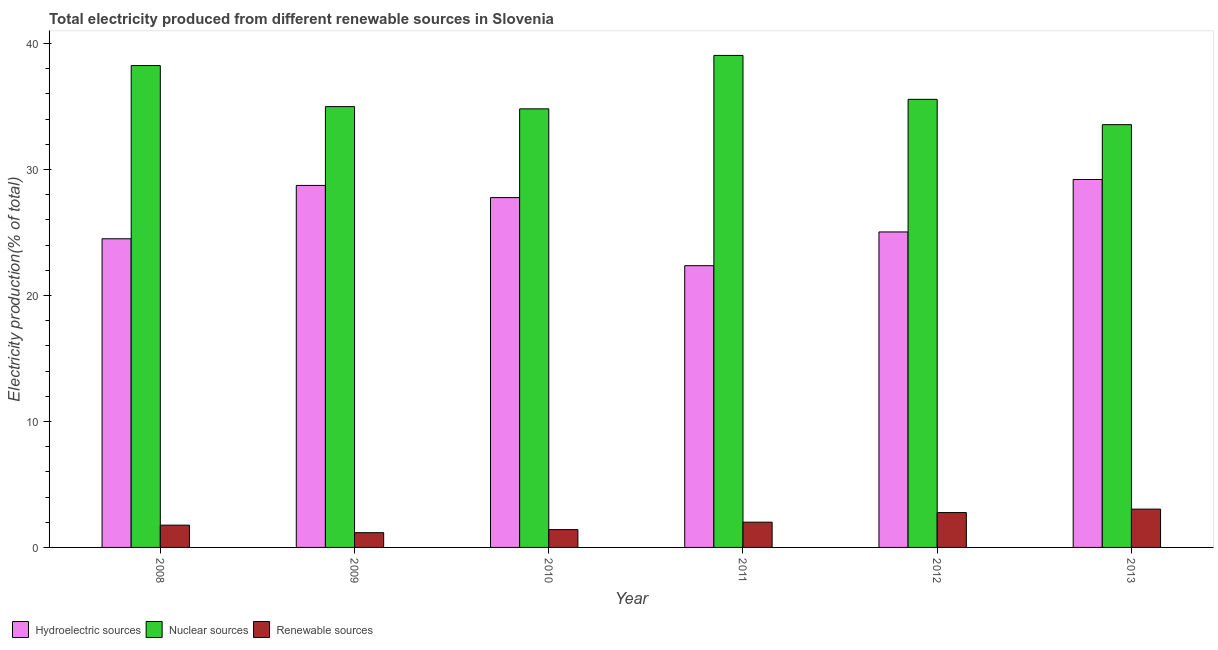How many groups of bars are there?
Offer a terse response. 6. Are the number of bars per tick equal to the number of legend labels?
Offer a very short reply. Yes. Are the number of bars on each tick of the X-axis equal?
Offer a very short reply. Yes. How many bars are there on the 5th tick from the right?
Keep it short and to the point. 3. What is the label of the 4th group of bars from the left?
Your answer should be very brief. 2011. What is the percentage of electricity produced by hydroelectric sources in 2011?
Provide a succinct answer. 22.37. Across all years, what is the maximum percentage of electricity produced by nuclear sources?
Your answer should be compact. 39.06. Across all years, what is the minimum percentage of electricity produced by nuclear sources?
Keep it short and to the point. 33.56. In which year was the percentage of electricity produced by renewable sources maximum?
Offer a very short reply. 2013. What is the total percentage of electricity produced by nuclear sources in the graph?
Your answer should be compact. 216.25. What is the difference between the percentage of electricity produced by hydroelectric sources in 2011 and that in 2012?
Provide a short and direct response. -2.68. What is the difference between the percentage of electricity produced by nuclear sources in 2011 and the percentage of electricity produced by renewable sources in 2012?
Provide a succinct answer. 3.49. What is the average percentage of electricity produced by renewable sources per year?
Your answer should be compact. 2.03. In how many years, is the percentage of electricity produced by hydroelectric sources greater than 2 %?
Keep it short and to the point. 6. What is the ratio of the percentage of electricity produced by nuclear sources in 2012 to that in 2013?
Offer a terse response. 1.06. Is the percentage of electricity produced by renewable sources in 2009 less than that in 2013?
Your answer should be compact. Yes. What is the difference between the highest and the second highest percentage of electricity produced by renewable sources?
Make the answer very short. 0.27. What is the difference between the highest and the lowest percentage of electricity produced by nuclear sources?
Ensure brevity in your answer.  5.5. In how many years, is the percentage of electricity produced by nuclear sources greater than the average percentage of electricity produced by nuclear sources taken over all years?
Ensure brevity in your answer.  2. Is the sum of the percentage of electricity produced by renewable sources in 2012 and 2013 greater than the maximum percentage of electricity produced by hydroelectric sources across all years?
Your answer should be compact. Yes. What does the 3rd bar from the left in 2011 represents?
Offer a terse response. Renewable sources. What does the 3rd bar from the right in 2008 represents?
Provide a succinct answer. Hydroelectric sources. Are all the bars in the graph horizontal?
Your answer should be compact. No. How many years are there in the graph?
Provide a short and direct response. 6. What is the difference between two consecutive major ticks on the Y-axis?
Provide a short and direct response. 10. Are the values on the major ticks of Y-axis written in scientific E-notation?
Provide a short and direct response. No. Where does the legend appear in the graph?
Give a very brief answer. Bottom left. How are the legend labels stacked?
Your response must be concise. Horizontal. What is the title of the graph?
Offer a terse response. Total electricity produced from different renewable sources in Slovenia. Does "Social Protection and Labor" appear as one of the legend labels in the graph?
Your response must be concise. No. What is the Electricity production(% of total) of Hydroelectric sources in 2008?
Provide a succinct answer. 24.5. What is the Electricity production(% of total) of Nuclear sources in 2008?
Ensure brevity in your answer.  38.25. What is the Electricity production(% of total) in Renewable sources in 2008?
Provide a succinct answer. 1.77. What is the Electricity production(% of total) of Hydroelectric sources in 2009?
Offer a very short reply. 28.74. What is the Electricity production(% of total) of Nuclear sources in 2009?
Ensure brevity in your answer.  34.99. What is the Electricity production(% of total) of Renewable sources in 2009?
Your answer should be compact. 1.17. What is the Electricity production(% of total) in Hydroelectric sources in 2010?
Your answer should be very brief. 27.77. What is the Electricity production(% of total) of Nuclear sources in 2010?
Ensure brevity in your answer.  34.82. What is the Electricity production(% of total) in Renewable sources in 2010?
Provide a short and direct response. 1.42. What is the Electricity production(% of total) of Hydroelectric sources in 2011?
Offer a very short reply. 22.37. What is the Electricity production(% of total) of Nuclear sources in 2011?
Your response must be concise. 39.06. What is the Electricity production(% of total) in Renewable sources in 2011?
Make the answer very short. 2. What is the Electricity production(% of total) in Hydroelectric sources in 2012?
Give a very brief answer. 25.04. What is the Electricity production(% of total) in Nuclear sources in 2012?
Offer a very short reply. 35.57. What is the Electricity production(% of total) in Renewable sources in 2012?
Your answer should be very brief. 2.77. What is the Electricity production(% of total) of Hydroelectric sources in 2013?
Provide a succinct answer. 29.21. What is the Electricity production(% of total) in Nuclear sources in 2013?
Ensure brevity in your answer.  33.56. What is the Electricity production(% of total) in Renewable sources in 2013?
Provide a short and direct response. 3.04. Across all years, what is the maximum Electricity production(% of total) in Hydroelectric sources?
Provide a succinct answer. 29.21. Across all years, what is the maximum Electricity production(% of total) of Nuclear sources?
Offer a terse response. 39.06. Across all years, what is the maximum Electricity production(% of total) in Renewable sources?
Your answer should be compact. 3.04. Across all years, what is the minimum Electricity production(% of total) in Hydroelectric sources?
Offer a terse response. 22.37. Across all years, what is the minimum Electricity production(% of total) of Nuclear sources?
Provide a short and direct response. 33.56. Across all years, what is the minimum Electricity production(% of total) in Renewable sources?
Your answer should be compact. 1.17. What is the total Electricity production(% of total) of Hydroelectric sources in the graph?
Make the answer very short. 157.63. What is the total Electricity production(% of total) in Nuclear sources in the graph?
Offer a terse response. 216.25. What is the total Electricity production(% of total) in Renewable sources in the graph?
Your answer should be compact. 12.17. What is the difference between the Electricity production(% of total) in Hydroelectric sources in 2008 and that in 2009?
Provide a succinct answer. -4.23. What is the difference between the Electricity production(% of total) in Nuclear sources in 2008 and that in 2009?
Provide a succinct answer. 3.26. What is the difference between the Electricity production(% of total) in Renewable sources in 2008 and that in 2009?
Offer a terse response. 0.6. What is the difference between the Electricity production(% of total) in Hydroelectric sources in 2008 and that in 2010?
Give a very brief answer. -3.27. What is the difference between the Electricity production(% of total) in Nuclear sources in 2008 and that in 2010?
Make the answer very short. 3.44. What is the difference between the Electricity production(% of total) in Renewable sources in 2008 and that in 2010?
Ensure brevity in your answer.  0.35. What is the difference between the Electricity production(% of total) of Hydroelectric sources in 2008 and that in 2011?
Offer a very short reply. 2.14. What is the difference between the Electricity production(% of total) in Nuclear sources in 2008 and that in 2011?
Ensure brevity in your answer.  -0.8. What is the difference between the Electricity production(% of total) in Renewable sources in 2008 and that in 2011?
Keep it short and to the point. -0.24. What is the difference between the Electricity production(% of total) of Hydroelectric sources in 2008 and that in 2012?
Provide a succinct answer. -0.54. What is the difference between the Electricity production(% of total) of Nuclear sources in 2008 and that in 2012?
Give a very brief answer. 2.68. What is the difference between the Electricity production(% of total) of Renewable sources in 2008 and that in 2012?
Offer a terse response. -1. What is the difference between the Electricity production(% of total) in Hydroelectric sources in 2008 and that in 2013?
Your answer should be very brief. -4.71. What is the difference between the Electricity production(% of total) of Nuclear sources in 2008 and that in 2013?
Provide a succinct answer. 4.69. What is the difference between the Electricity production(% of total) of Renewable sources in 2008 and that in 2013?
Ensure brevity in your answer.  -1.27. What is the difference between the Electricity production(% of total) of Hydroelectric sources in 2009 and that in 2010?
Provide a short and direct response. 0.97. What is the difference between the Electricity production(% of total) of Nuclear sources in 2009 and that in 2010?
Give a very brief answer. 0.18. What is the difference between the Electricity production(% of total) of Renewable sources in 2009 and that in 2010?
Your answer should be very brief. -0.24. What is the difference between the Electricity production(% of total) in Hydroelectric sources in 2009 and that in 2011?
Provide a short and direct response. 6.37. What is the difference between the Electricity production(% of total) of Nuclear sources in 2009 and that in 2011?
Provide a succinct answer. -4.06. What is the difference between the Electricity production(% of total) in Renewable sources in 2009 and that in 2011?
Ensure brevity in your answer.  -0.83. What is the difference between the Electricity production(% of total) in Hydroelectric sources in 2009 and that in 2012?
Give a very brief answer. 3.69. What is the difference between the Electricity production(% of total) of Nuclear sources in 2009 and that in 2012?
Keep it short and to the point. -0.58. What is the difference between the Electricity production(% of total) of Renewable sources in 2009 and that in 2012?
Your answer should be very brief. -1.6. What is the difference between the Electricity production(% of total) in Hydroelectric sources in 2009 and that in 2013?
Give a very brief answer. -0.47. What is the difference between the Electricity production(% of total) of Nuclear sources in 2009 and that in 2013?
Offer a terse response. 1.43. What is the difference between the Electricity production(% of total) in Renewable sources in 2009 and that in 2013?
Your answer should be compact. -1.87. What is the difference between the Electricity production(% of total) in Hydroelectric sources in 2010 and that in 2011?
Offer a very short reply. 5.4. What is the difference between the Electricity production(% of total) of Nuclear sources in 2010 and that in 2011?
Keep it short and to the point. -4.24. What is the difference between the Electricity production(% of total) of Renewable sources in 2010 and that in 2011?
Make the answer very short. -0.59. What is the difference between the Electricity production(% of total) of Hydroelectric sources in 2010 and that in 2012?
Your answer should be compact. 2.73. What is the difference between the Electricity production(% of total) of Nuclear sources in 2010 and that in 2012?
Offer a very short reply. -0.75. What is the difference between the Electricity production(% of total) in Renewable sources in 2010 and that in 2012?
Keep it short and to the point. -1.35. What is the difference between the Electricity production(% of total) in Hydroelectric sources in 2010 and that in 2013?
Offer a terse response. -1.44. What is the difference between the Electricity production(% of total) in Nuclear sources in 2010 and that in 2013?
Ensure brevity in your answer.  1.26. What is the difference between the Electricity production(% of total) in Renewable sources in 2010 and that in 2013?
Your answer should be very brief. -1.62. What is the difference between the Electricity production(% of total) in Hydroelectric sources in 2011 and that in 2012?
Offer a terse response. -2.68. What is the difference between the Electricity production(% of total) of Nuclear sources in 2011 and that in 2012?
Give a very brief answer. 3.49. What is the difference between the Electricity production(% of total) in Renewable sources in 2011 and that in 2012?
Make the answer very short. -0.76. What is the difference between the Electricity production(% of total) in Hydroelectric sources in 2011 and that in 2013?
Give a very brief answer. -6.84. What is the difference between the Electricity production(% of total) in Nuclear sources in 2011 and that in 2013?
Your answer should be compact. 5.5. What is the difference between the Electricity production(% of total) in Renewable sources in 2011 and that in 2013?
Your response must be concise. -1.03. What is the difference between the Electricity production(% of total) in Hydroelectric sources in 2012 and that in 2013?
Offer a very short reply. -4.17. What is the difference between the Electricity production(% of total) of Nuclear sources in 2012 and that in 2013?
Ensure brevity in your answer.  2.01. What is the difference between the Electricity production(% of total) of Renewable sources in 2012 and that in 2013?
Provide a short and direct response. -0.27. What is the difference between the Electricity production(% of total) of Hydroelectric sources in 2008 and the Electricity production(% of total) of Nuclear sources in 2009?
Offer a terse response. -10.49. What is the difference between the Electricity production(% of total) of Hydroelectric sources in 2008 and the Electricity production(% of total) of Renewable sources in 2009?
Your answer should be very brief. 23.33. What is the difference between the Electricity production(% of total) of Nuclear sources in 2008 and the Electricity production(% of total) of Renewable sources in 2009?
Your answer should be very brief. 37.08. What is the difference between the Electricity production(% of total) of Hydroelectric sources in 2008 and the Electricity production(% of total) of Nuclear sources in 2010?
Offer a very short reply. -10.32. What is the difference between the Electricity production(% of total) in Hydroelectric sources in 2008 and the Electricity production(% of total) in Renewable sources in 2010?
Your answer should be compact. 23.09. What is the difference between the Electricity production(% of total) in Nuclear sources in 2008 and the Electricity production(% of total) in Renewable sources in 2010?
Provide a short and direct response. 36.84. What is the difference between the Electricity production(% of total) of Hydroelectric sources in 2008 and the Electricity production(% of total) of Nuclear sources in 2011?
Your response must be concise. -14.55. What is the difference between the Electricity production(% of total) of Hydroelectric sources in 2008 and the Electricity production(% of total) of Renewable sources in 2011?
Ensure brevity in your answer.  22.5. What is the difference between the Electricity production(% of total) in Nuclear sources in 2008 and the Electricity production(% of total) in Renewable sources in 2011?
Your response must be concise. 36.25. What is the difference between the Electricity production(% of total) in Hydroelectric sources in 2008 and the Electricity production(% of total) in Nuclear sources in 2012?
Provide a short and direct response. -11.07. What is the difference between the Electricity production(% of total) of Hydroelectric sources in 2008 and the Electricity production(% of total) of Renewable sources in 2012?
Provide a short and direct response. 21.73. What is the difference between the Electricity production(% of total) in Nuclear sources in 2008 and the Electricity production(% of total) in Renewable sources in 2012?
Ensure brevity in your answer.  35.49. What is the difference between the Electricity production(% of total) in Hydroelectric sources in 2008 and the Electricity production(% of total) in Nuclear sources in 2013?
Ensure brevity in your answer.  -9.06. What is the difference between the Electricity production(% of total) of Hydroelectric sources in 2008 and the Electricity production(% of total) of Renewable sources in 2013?
Your response must be concise. 21.46. What is the difference between the Electricity production(% of total) of Nuclear sources in 2008 and the Electricity production(% of total) of Renewable sources in 2013?
Offer a terse response. 35.21. What is the difference between the Electricity production(% of total) in Hydroelectric sources in 2009 and the Electricity production(% of total) in Nuclear sources in 2010?
Provide a short and direct response. -6.08. What is the difference between the Electricity production(% of total) of Hydroelectric sources in 2009 and the Electricity production(% of total) of Renewable sources in 2010?
Provide a short and direct response. 27.32. What is the difference between the Electricity production(% of total) in Nuclear sources in 2009 and the Electricity production(% of total) in Renewable sources in 2010?
Offer a very short reply. 33.58. What is the difference between the Electricity production(% of total) of Hydroelectric sources in 2009 and the Electricity production(% of total) of Nuclear sources in 2011?
Ensure brevity in your answer.  -10.32. What is the difference between the Electricity production(% of total) of Hydroelectric sources in 2009 and the Electricity production(% of total) of Renewable sources in 2011?
Provide a short and direct response. 26.73. What is the difference between the Electricity production(% of total) of Nuclear sources in 2009 and the Electricity production(% of total) of Renewable sources in 2011?
Ensure brevity in your answer.  32.99. What is the difference between the Electricity production(% of total) in Hydroelectric sources in 2009 and the Electricity production(% of total) in Nuclear sources in 2012?
Your answer should be very brief. -6.83. What is the difference between the Electricity production(% of total) in Hydroelectric sources in 2009 and the Electricity production(% of total) in Renewable sources in 2012?
Keep it short and to the point. 25.97. What is the difference between the Electricity production(% of total) in Nuclear sources in 2009 and the Electricity production(% of total) in Renewable sources in 2012?
Offer a terse response. 32.22. What is the difference between the Electricity production(% of total) of Hydroelectric sources in 2009 and the Electricity production(% of total) of Nuclear sources in 2013?
Provide a succinct answer. -4.82. What is the difference between the Electricity production(% of total) of Hydroelectric sources in 2009 and the Electricity production(% of total) of Renewable sources in 2013?
Offer a terse response. 25.7. What is the difference between the Electricity production(% of total) in Nuclear sources in 2009 and the Electricity production(% of total) in Renewable sources in 2013?
Your answer should be very brief. 31.95. What is the difference between the Electricity production(% of total) of Hydroelectric sources in 2010 and the Electricity production(% of total) of Nuclear sources in 2011?
Provide a short and direct response. -11.29. What is the difference between the Electricity production(% of total) of Hydroelectric sources in 2010 and the Electricity production(% of total) of Renewable sources in 2011?
Your response must be concise. 25.76. What is the difference between the Electricity production(% of total) of Nuclear sources in 2010 and the Electricity production(% of total) of Renewable sources in 2011?
Offer a terse response. 32.81. What is the difference between the Electricity production(% of total) in Hydroelectric sources in 2010 and the Electricity production(% of total) in Nuclear sources in 2012?
Offer a terse response. -7.8. What is the difference between the Electricity production(% of total) of Hydroelectric sources in 2010 and the Electricity production(% of total) of Renewable sources in 2012?
Give a very brief answer. 25. What is the difference between the Electricity production(% of total) of Nuclear sources in 2010 and the Electricity production(% of total) of Renewable sources in 2012?
Your response must be concise. 32.05. What is the difference between the Electricity production(% of total) in Hydroelectric sources in 2010 and the Electricity production(% of total) in Nuclear sources in 2013?
Your answer should be compact. -5.79. What is the difference between the Electricity production(% of total) of Hydroelectric sources in 2010 and the Electricity production(% of total) of Renewable sources in 2013?
Ensure brevity in your answer.  24.73. What is the difference between the Electricity production(% of total) in Nuclear sources in 2010 and the Electricity production(% of total) in Renewable sources in 2013?
Offer a terse response. 31.78. What is the difference between the Electricity production(% of total) of Hydroelectric sources in 2011 and the Electricity production(% of total) of Nuclear sources in 2012?
Give a very brief answer. -13.21. What is the difference between the Electricity production(% of total) in Hydroelectric sources in 2011 and the Electricity production(% of total) in Renewable sources in 2012?
Provide a succinct answer. 19.6. What is the difference between the Electricity production(% of total) in Nuclear sources in 2011 and the Electricity production(% of total) in Renewable sources in 2012?
Give a very brief answer. 36.29. What is the difference between the Electricity production(% of total) in Hydroelectric sources in 2011 and the Electricity production(% of total) in Nuclear sources in 2013?
Provide a short and direct response. -11.19. What is the difference between the Electricity production(% of total) in Hydroelectric sources in 2011 and the Electricity production(% of total) in Renewable sources in 2013?
Provide a succinct answer. 19.33. What is the difference between the Electricity production(% of total) in Nuclear sources in 2011 and the Electricity production(% of total) in Renewable sources in 2013?
Offer a very short reply. 36.02. What is the difference between the Electricity production(% of total) of Hydroelectric sources in 2012 and the Electricity production(% of total) of Nuclear sources in 2013?
Provide a short and direct response. -8.52. What is the difference between the Electricity production(% of total) in Hydroelectric sources in 2012 and the Electricity production(% of total) in Renewable sources in 2013?
Keep it short and to the point. 22. What is the difference between the Electricity production(% of total) in Nuclear sources in 2012 and the Electricity production(% of total) in Renewable sources in 2013?
Make the answer very short. 32.53. What is the average Electricity production(% of total) in Hydroelectric sources per year?
Make the answer very short. 26.27. What is the average Electricity production(% of total) in Nuclear sources per year?
Ensure brevity in your answer.  36.04. What is the average Electricity production(% of total) of Renewable sources per year?
Give a very brief answer. 2.03. In the year 2008, what is the difference between the Electricity production(% of total) in Hydroelectric sources and Electricity production(% of total) in Nuclear sources?
Your answer should be compact. -13.75. In the year 2008, what is the difference between the Electricity production(% of total) of Hydroelectric sources and Electricity production(% of total) of Renewable sources?
Your answer should be very brief. 22.73. In the year 2008, what is the difference between the Electricity production(% of total) in Nuclear sources and Electricity production(% of total) in Renewable sources?
Ensure brevity in your answer.  36.48. In the year 2009, what is the difference between the Electricity production(% of total) in Hydroelectric sources and Electricity production(% of total) in Nuclear sources?
Make the answer very short. -6.26. In the year 2009, what is the difference between the Electricity production(% of total) in Hydroelectric sources and Electricity production(% of total) in Renewable sources?
Give a very brief answer. 27.57. In the year 2009, what is the difference between the Electricity production(% of total) in Nuclear sources and Electricity production(% of total) in Renewable sources?
Provide a succinct answer. 33.82. In the year 2010, what is the difference between the Electricity production(% of total) of Hydroelectric sources and Electricity production(% of total) of Nuclear sources?
Provide a short and direct response. -7.05. In the year 2010, what is the difference between the Electricity production(% of total) in Hydroelectric sources and Electricity production(% of total) in Renewable sources?
Offer a terse response. 26.35. In the year 2010, what is the difference between the Electricity production(% of total) of Nuclear sources and Electricity production(% of total) of Renewable sources?
Your response must be concise. 33.4. In the year 2011, what is the difference between the Electricity production(% of total) of Hydroelectric sources and Electricity production(% of total) of Nuclear sources?
Your answer should be very brief. -16.69. In the year 2011, what is the difference between the Electricity production(% of total) of Hydroelectric sources and Electricity production(% of total) of Renewable sources?
Give a very brief answer. 20.36. In the year 2011, what is the difference between the Electricity production(% of total) in Nuclear sources and Electricity production(% of total) in Renewable sources?
Ensure brevity in your answer.  37.05. In the year 2012, what is the difference between the Electricity production(% of total) in Hydroelectric sources and Electricity production(% of total) in Nuclear sources?
Your response must be concise. -10.53. In the year 2012, what is the difference between the Electricity production(% of total) of Hydroelectric sources and Electricity production(% of total) of Renewable sources?
Offer a terse response. 22.28. In the year 2012, what is the difference between the Electricity production(% of total) in Nuclear sources and Electricity production(% of total) in Renewable sources?
Provide a short and direct response. 32.8. In the year 2013, what is the difference between the Electricity production(% of total) in Hydroelectric sources and Electricity production(% of total) in Nuclear sources?
Your answer should be very brief. -4.35. In the year 2013, what is the difference between the Electricity production(% of total) in Hydroelectric sources and Electricity production(% of total) in Renewable sources?
Your answer should be compact. 26.17. In the year 2013, what is the difference between the Electricity production(% of total) of Nuclear sources and Electricity production(% of total) of Renewable sources?
Make the answer very short. 30.52. What is the ratio of the Electricity production(% of total) in Hydroelectric sources in 2008 to that in 2009?
Offer a terse response. 0.85. What is the ratio of the Electricity production(% of total) of Nuclear sources in 2008 to that in 2009?
Your answer should be compact. 1.09. What is the ratio of the Electricity production(% of total) in Renewable sources in 2008 to that in 2009?
Provide a short and direct response. 1.51. What is the ratio of the Electricity production(% of total) in Hydroelectric sources in 2008 to that in 2010?
Your response must be concise. 0.88. What is the ratio of the Electricity production(% of total) of Nuclear sources in 2008 to that in 2010?
Offer a very short reply. 1.1. What is the ratio of the Electricity production(% of total) of Renewable sources in 2008 to that in 2010?
Offer a very short reply. 1.25. What is the ratio of the Electricity production(% of total) of Hydroelectric sources in 2008 to that in 2011?
Offer a very short reply. 1.1. What is the ratio of the Electricity production(% of total) of Nuclear sources in 2008 to that in 2011?
Give a very brief answer. 0.98. What is the ratio of the Electricity production(% of total) of Renewable sources in 2008 to that in 2011?
Keep it short and to the point. 0.88. What is the ratio of the Electricity production(% of total) in Hydroelectric sources in 2008 to that in 2012?
Your answer should be compact. 0.98. What is the ratio of the Electricity production(% of total) of Nuclear sources in 2008 to that in 2012?
Make the answer very short. 1.08. What is the ratio of the Electricity production(% of total) of Renewable sources in 2008 to that in 2012?
Provide a short and direct response. 0.64. What is the ratio of the Electricity production(% of total) in Hydroelectric sources in 2008 to that in 2013?
Your answer should be very brief. 0.84. What is the ratio of the Electricity production(% of total) of Nuclear sources in 2008 to that in 2013?
Your answer should be compact. 1.14. What is the ratio of the Electricity production(% of total) in Renewable sources in 2008 to that in 2013?
Ensure brevity in your answer.  0.58. What is the ratio of the Electricity production(% of total) of Hydroelectric sources in 2009 to that in 2010?
Your answer should be very brief. 1.03. What is the ratio of the Electricity production(% of total) of Renewable sources in 2009 to that in 2010?
Your answer should be very brief. 0.83. What is the ratio of the Electricity production(% of total) in Hydroelectric sources in 2009 to that in 2011?
Your answer should be very brief. 1.28. What is the ratio of the Electricity production(% of total) of Nuclear sources in 2009 to that in 2011?
Your answer should be compact. 0.9. What is the ratio of the Electricity production(% of total) of Renewable sources in 2009 to that in 2011?
Your answer should be very brief. 0.58. What is the ratio of the Electricity production(% of total) of Hydroelectric sources in 2009 to that in 2012?
Your answer should be compact. 1.15. What is the ratio of the Electricity production(% of total) in Nuclear sources in 2009 to that in 2012?
Your response must be concise. 0.98. What is the ratio of the Electricity production(% of total) in Renewable sources in 2009 to that in 2012?
Provide a succinct answer. 0.42. What is the ratio of the Electricity production(% of total) of Hydroelectric sources in 2009 to that in 2013?
Keep it short and to the point. 0.98. What is the ratio of the Electricity production(% of total) of Nuclear sources in 2009 to that in 2013?
Make the answer very short. 1.04. What is the ratio of the Electricity production(% of total) in Renewable sources in 2009 to that in 2013?
Give a very brief answer. 0.39. What is the ratio of the Electricity production(% of total) of Hydroelectric sources in 2010 to that in 2011?
Ensure brevity in your answer.  1.24. What is the ratio of the Electricity production(% of total) of Nuclear sources in 2010 to that in 2011?
Make the answer very short. 0.89. What is the ratio of the Electricity production(% of total) of Renewable sources in 2010 to that in 2011?
Your response must be concise. 0.71. What is the ratio of the Electricity production(% of total) of Hydroelectric sources in 2010 to that in 2012?
Offer a terse response. 1.11. What is the ratio of the Electricity production(% of total) of Nuclear sources in 2010 to that in 2012?
Provide a succinct answer. 0.98. What is the ratio of the Electricity production(% of total) of Renewable sources in 2010 to that in 2012?
Your response must be concise. 0.51. What is the ratio of the Electricity production(% of total) of Hydroelectric sources in 2010 to that in 2013?
Offer a very short reply. 0.95. What is the ratio of the Electricity production(% of total) of Nuclear sources in 2010 to that in 2013?
Make the answer very short. 1.04. What is the ratio of the Electricity production(% of total) in Renewable sources in 2010 to that in 2013?
Make the answer very short. 0.47. What is the ratio of the Electricity production(% of total) of Hydroelectric sources in 2011 to that in 2012?
Make the answer very short. 0.89. What is the ratio of the Electricity production(% of total) in Nuclear sources in 2011 to that in 2012?
Give a very brief answer. 1.1. What is the ratio of the Electricity production(% of total) in Renewable sources in 2011 to that in 2012?
Keep it short and to the point. 0.72. What is the ratio of the Electricity production(% of total) in Hydroelectric sources in 2011 to that in 2013?
Make the answer very short. 0.77. What is the ratio of the Electricity production(% of total) in Nuclear sources in 2011 to that in 2013?
Ensure brevity in your answer.  1.16. What is the ratio of the Electricity production(% of total) in Renewable sources in 2011 to that in 2013?
Your answer should be very brief. 0.66. What is the ratio of the Electricity production(% of total) in Hydroelectric sources in 2012 to that in 2013?
Your answer should be very brief. 0.86. What is the ratio of the Electricity production(% of total) of Nuclear sources in 2012 to that in 2013?
Provide a short and direct response. 1.06. What is the ratio of the Electricity production(% of total) of Renewable sources in 2012 to that in 2013?
Your answer should be compact. 0.91. What is the difference between the highest and the second highest Electricity production(% of total) in Hydroelectric sources?
Ensure brevity in your answer.  0.47. What is the difference between the highest and the second highest Electricity production(% of total) of Nuclear sources?
Offer a terse response. 0.8. What is the difference between the highest and the second highest Electricity production(% of total) of Renewable sources?
Give a very brief answer. 0.27. What is the difference between the highest and the lowest Electricity production(% of total) of Hydroelectric sources?
Your answer should be very brief. 6.84. What is the difference between the highest and the lowest Electricity production(% of total) of Nuclear sources?
Offer a very short reply. 5.5. What is the difference between the highest and the lowest Electricity production(% of total) of Renewable sources?
Your answer should be compact. 1.87. 